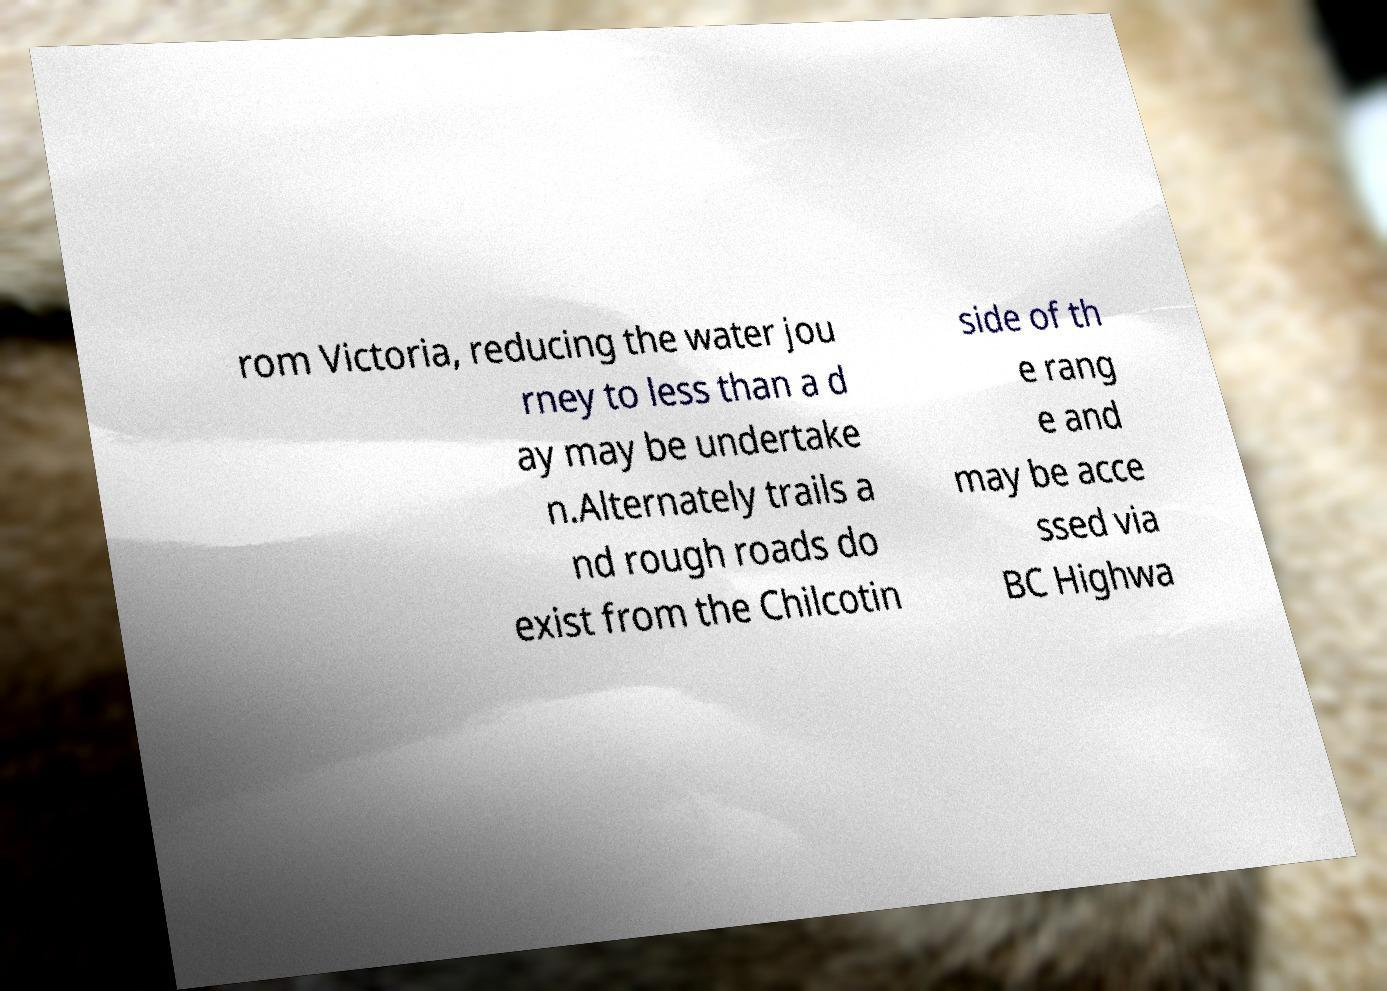I need the written content from this picture converted into text. Can you do that? rom Victoria, reducing the water jou rney to less than a d ay may be undertake n.Alternately trails a nd rough roads do exist from the Chilcotin side of th e rang e and may be acce ssed via BC Highwa 